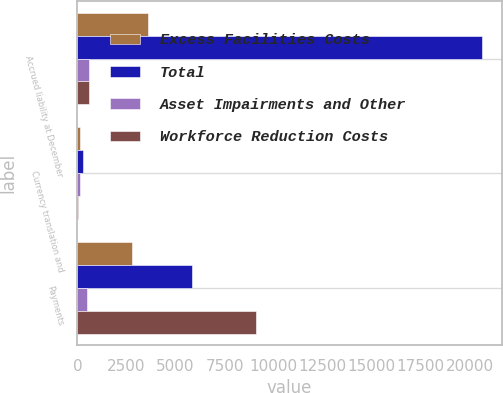Convert chart. <chart><loc_0><loc_0><loc_500><loc_500><stacked_bar_chart><ecel><fcel>Accrued liability at December<fcel>Currency translation and<fcel>Payments<nl><fcel>Excess Facilities Costs<fcel>3591<fcel>113<fcel>2797<nl><fcel>Total<fcel>20595<fcel>284<fcel>5849<nl><fcel>Asset Impairments and Other<fcel>587<fcel>120<fcel>467<nl><fcel>Workforce Reduction Costs<fcel>587<fcel>51<fcel>9113<nl></chart> 